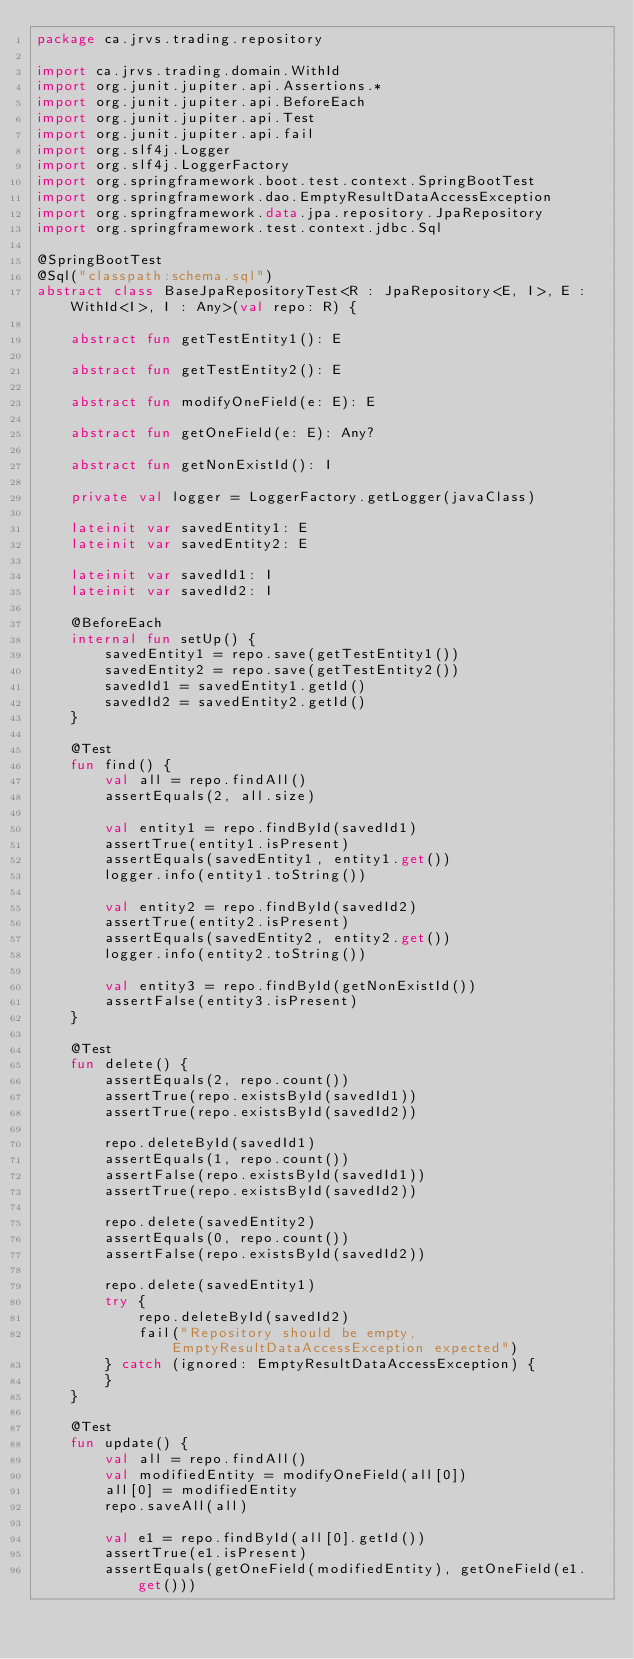Convert code to text. <code><loc_0><loc_0><loc_500><loc_500><_Kotlin_>package ca.jrvs.trading.repository

import ca.jrvs.trading.domain.WithId
import org.junit.jupiter.api.Assertions.*
import org.junit.jupiter.api.BeforeEach
import org.junit.jupiter.api.Test
import org.junit.jupiter.api.fail
import org.slf4j.Logger
import org.slf4j.LoggerFactory
import org.springframework.boot.test.context.SpringBootTest
import org.springframework.dao.EmptyResultDataAccessException
import org.springframework.data.jpa.repository.JpaRepository
import org.springframework.test.context.jdbc.Sql

@SpringBootTest
@Sql("classpath:schema.sql")
abstract class BaseJpaRepositoryTest<R : JpaRepository<E, I>, E : WithId<I>, I : Any>(val repo: R) {

    abstract fun getTestEntity1(): E

    abstract fun getTestEntity2(): E

    abstract fun modifyOneField(e: E): E

    abstract fun getOneField(e: E): Any?

    abstract fun getNonExistId(): I

    private val logger = LoggerFactory.getLogger(javaClass)

    lateinit var savedEntity1: E
    lateinit var savedEntity2: E

    lateinit var savedId1: I
    lateinit var savedId2: I

    @BeforeEach
    internal fun setUp() {
        savedEntity1 = repo.save(getTestEntity1())
        savedEntity2 = repo.save(getTestEntity2())
        savedId1 = savedEntity1.getId()
        savedId2 = savedEntity2.getId()
    }

    @Test
    fun find() {
        val all = repo.findAll()
        assertEquals(2, all.size)

        val entity1 = repo.findById(savedId1)
        assertTrue(entity1.isPresent)
        assertEquals(savedEntity1, entity1.get())
        logger.info(entity1.toString())

        val entity2 = repo.findById(savedId2)
        assertTrue(entity2.isPresent)
        assertEquals(savedEntity2, entity2.get())
        logger.info(entity2.toString())

        val entity3 = repo.findById(getNonExistId())
        assertFalse(entity3.isPresent)
    }

    @Test
    fun delete() {
        assertEquals(2, repo.count())
        assertTrue(repo.existsById(savedId1))
        assertTrue(repo.existsById(savedId2))

        repo.deleteById(savedId1)
        assertEquals(1, repo.count())
        assertFalse(repo.existsById(savedId1))
        assertTrue(repo.existsById(savedId2))

        repo.delete(savedEntity2)
        assertEquals(0, repo.count())
        assertFalse(repo.existsById(savedId2))

        repo.delete(savedEntity1)
        try {
            repo.deleteById(savedId2)
            fail("Repository should be empty, EmptyResultDataAccessException expected")
        } catch (ignored: EmptyResultDataAccessException) {
        }
    }

    @Test
    fun update() {
        val all = repo.findAll()
        val modifiedEntity = modifyOneField(all[0])
        all[0] = modifiedEntity
        repo.saveAll(all)

        val e1 = repo.findById(all[0].getId())
        assertTrue(e1.isPresent)
        assertEquals(getOneField(modifiedEntity), getOneField(e1.get()))
</code> 